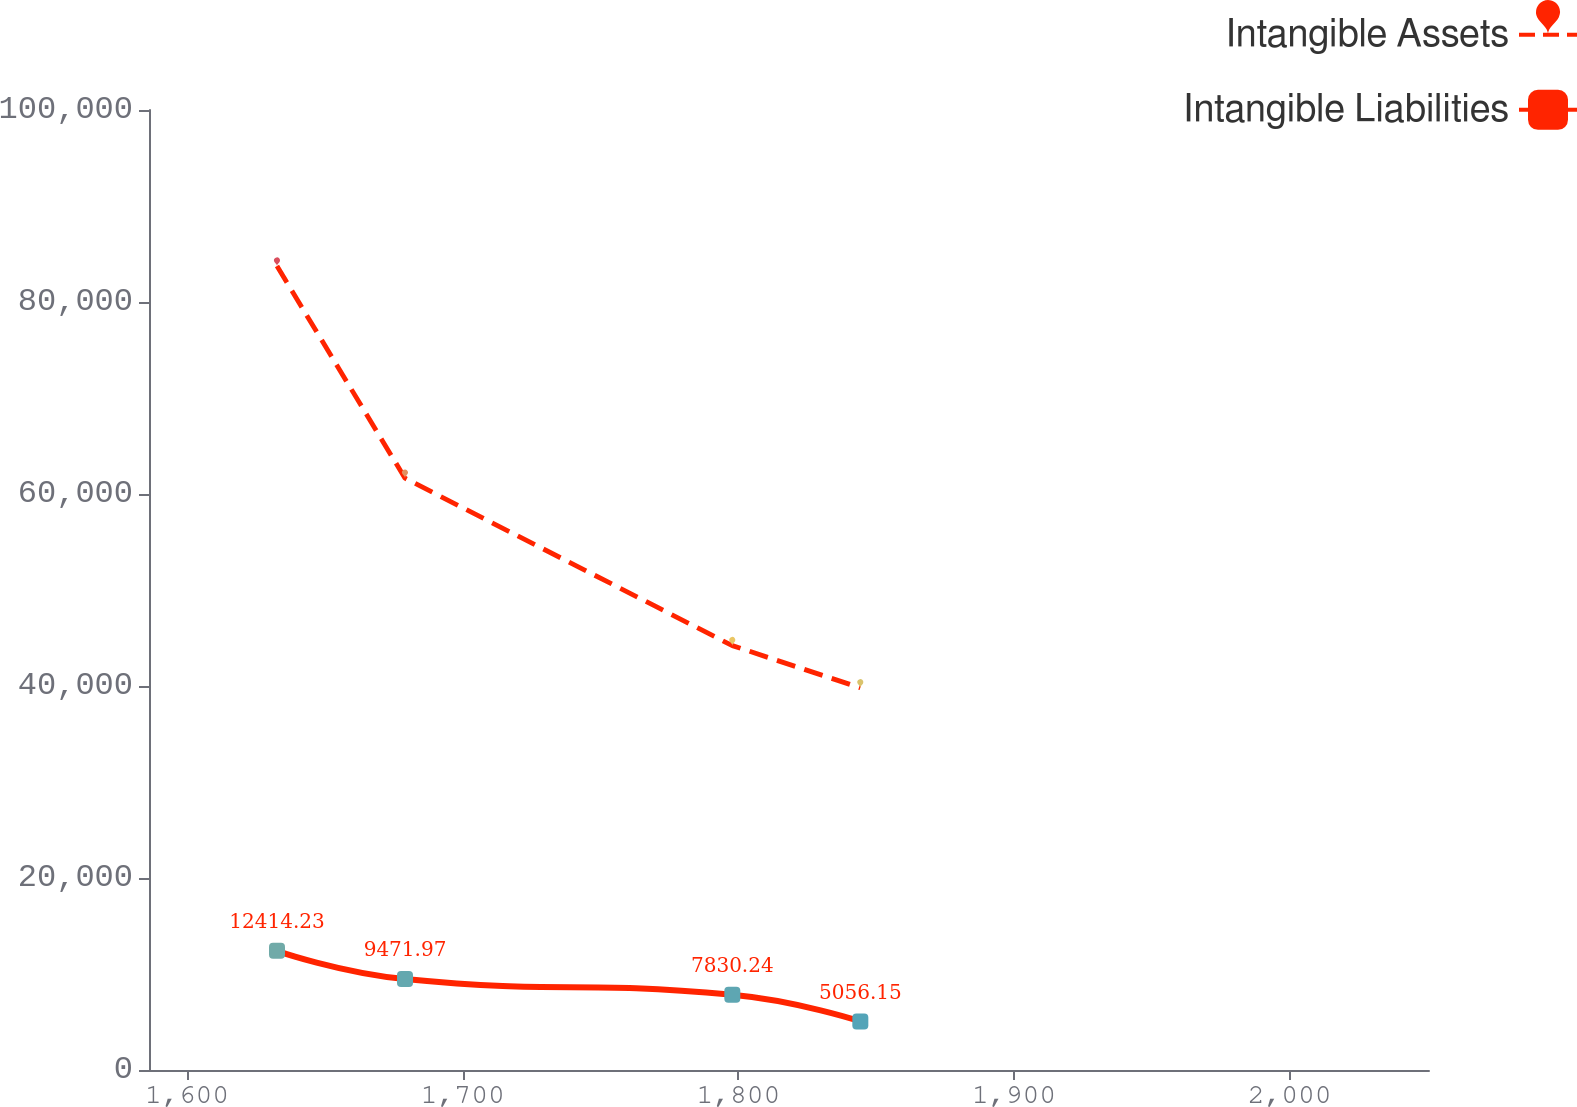Convert chart to OTSL. <chart><loc_0><loc_0><loc_500><loc_500><line_chart><ecel><fcel>Intangible Assets<fcel>Intangible Liabilities<nl><fcel>1632.61<fcel>83740.5<fcel>12414.2<nl><fcel>1679.05<fcel>61642.8<fcel>9471.97<nl><fcel>1797.8<fcel>44203.1<fcel>7830.24<nl><fcel>1844.24<fcel>39810.1<fcel>5056.15<nl><fcel>2096.99<fcel>48596.2<fcel>4238.59<nl></chart> 